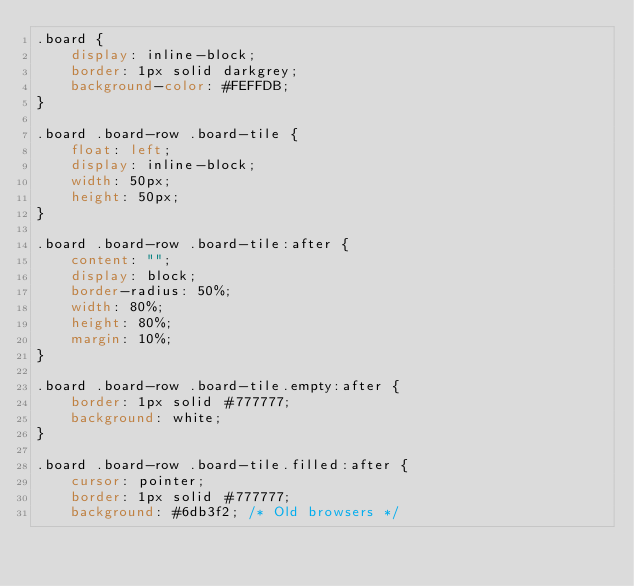Convert code to text. <code><loc_0><loc_0><loc_500><loc_500><_CSS_>.board {
    display: inline-block;
    border: 1px solid darkgrey;
    background-color: #FEFFDB;
}

.board .board-row .board-tile {
    float: left;
    display: inline-block;
    width: 50px;
    height: 50px;
}

.board .board-row .board-tile:after {
    content: "";
    display: block;
    border-radius: 50%;
    width: 80%;
    height: 80%;
    margin: 10%;
}

.board .board-row .board-tile.empty:after {
    border: 1px solid #777777;
    background: white;
}

.board .board-row .board-tile.filled:after {
    cursor: pointer;
    border: 1px solid #777777;
    background: #6db3f2; /* Old browsers */</code> 